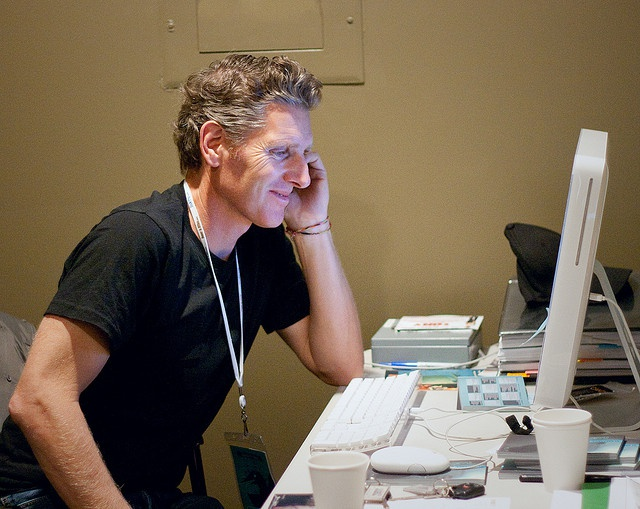Describe the objects in this image and their specific colors. I can see people in olive, black, gray, maroon, and tan tones, tv in olive, darkgray, and lightgray tones, keyboard in olive, lightgray, and darkgray tones, book in olive, gray, black, and darkgray tones, and handbag in olive, black, and gray tones in this image. 